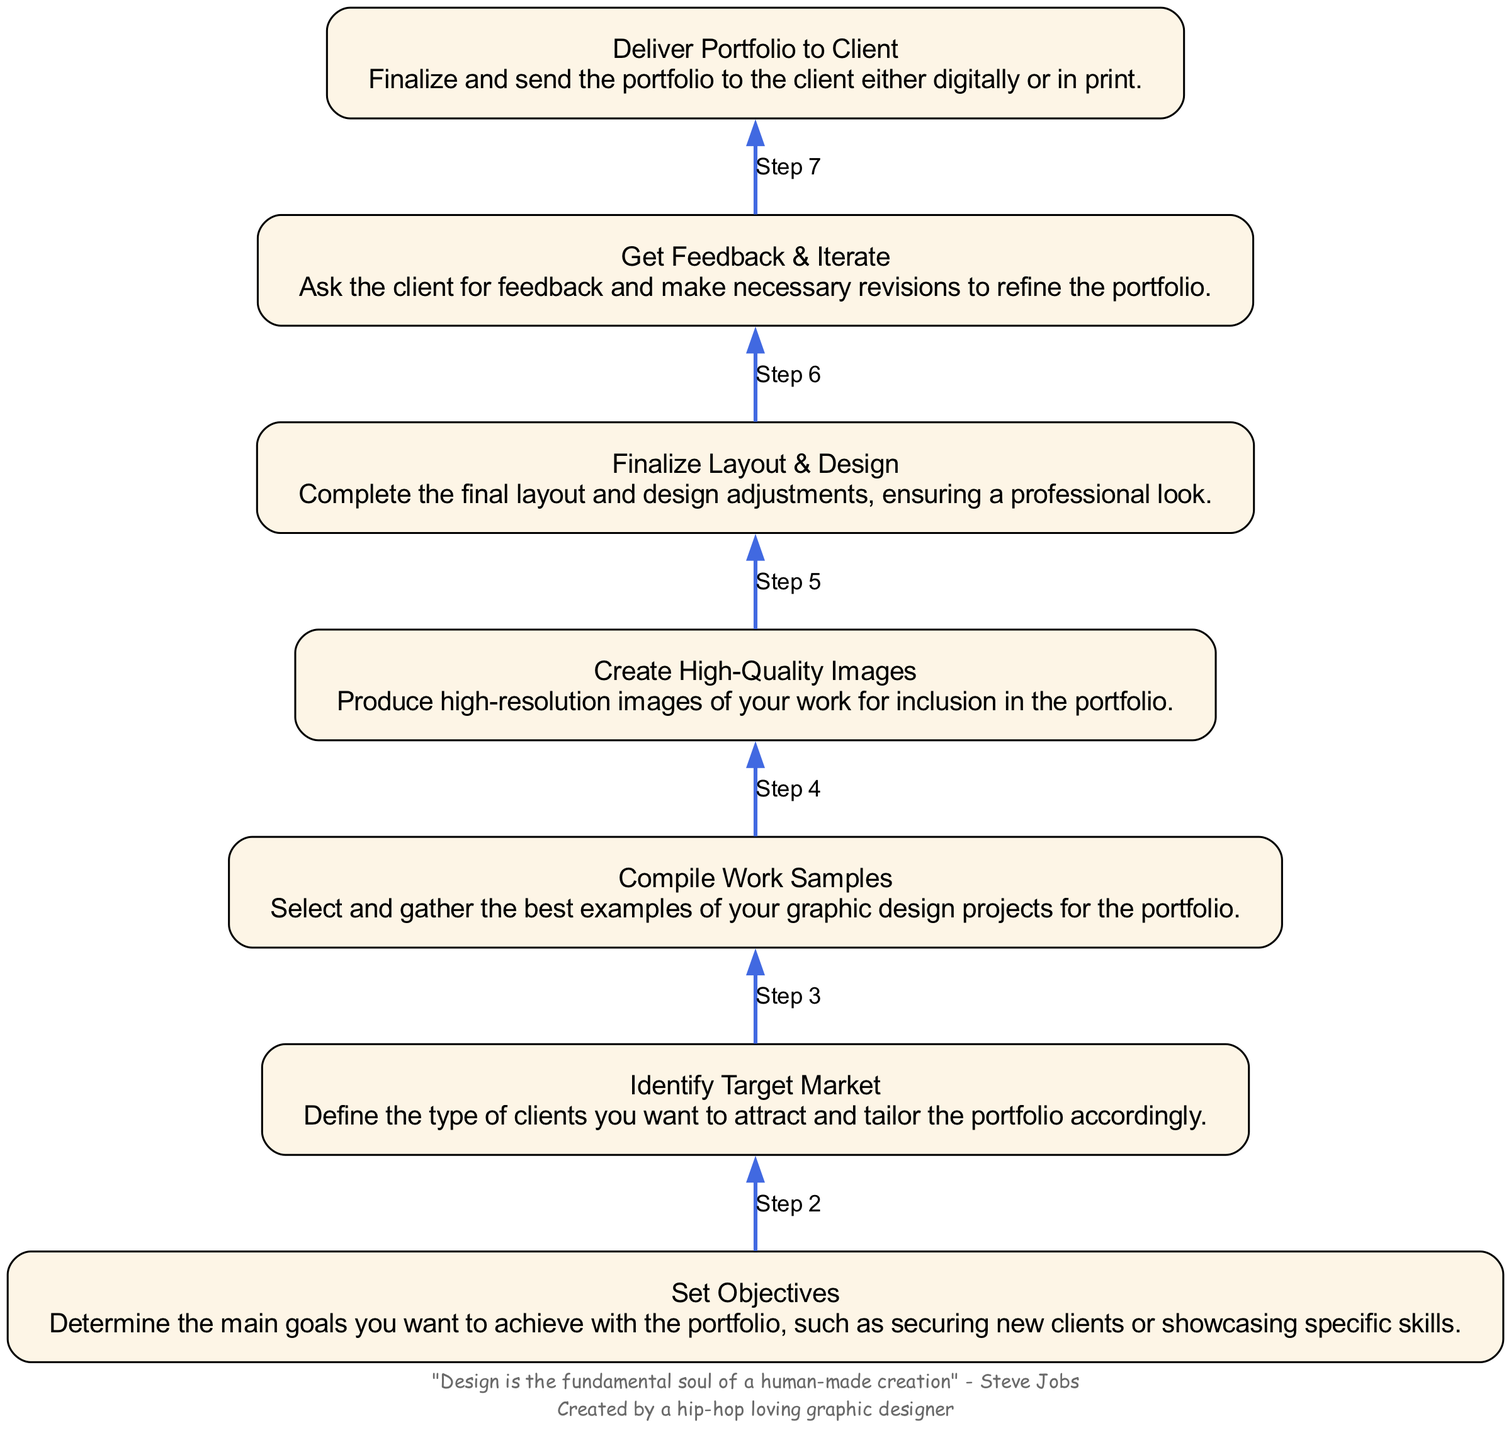What is the final step in the diagram? The final node in the flowchart is "Deliver Portfolio to Client," indicating that this is the last action to be taken in preparing the graphic design portfolio.
Answer: Deliver Portfolio to Client How many steps are there in the portfolio preparation process? By counting the nodes in the diagram, there are a total of seven steps involved in preparing the graphic design portfolio.
Answer: 7 Which step involves gathering project examples? The node labeled "Compile Work Samples" specifically addresses the task of selecting and gathering the best examples of graphic design projects for inclusion in the portfolio.
Answer: Compile Work Samples What is the first step in the diagram? The first node at the bottom of the flowchart is "Set Objectives," indicating that determining the main goals is the initial action in the portfolio preparation process.
Answer: Set Objectives Which two steps come before "Finalize Layout & Design"? The steps that lead up to "Finalize Layout & Design" are "Get Feedback & Iterate" and "Create High-Quality Images," which precede it in the flow sequence.
Answer: Get Feedback & Iterate, Create High-Quality Images What is the relationship between "Identify Target Market" and "Set Objectives"? "Identify Target Market" follows "Set Objectives" in the flow sequence, suggesting that defining client types comes after determining the main goals for the portfolio.
Answer: Identify Target Market follows Set Objectives What can be inferred about the purpose of the flowchart? The flowchart aims to provide a clear, step-by-step process on how to prepare a graphic design portfolio tailored to attract clients, organized from initial objectives to final delivery.
Answer: Preparation of graphic design portfolio What type of design is emphasized in the "Deliver Portfolio to Client" step? The emphasis here is on the completion and professionalism of the portfolio delivery, as indicated by the importance of finalizing and sending the portfolio in a polished manner.
Answer: Professional look 